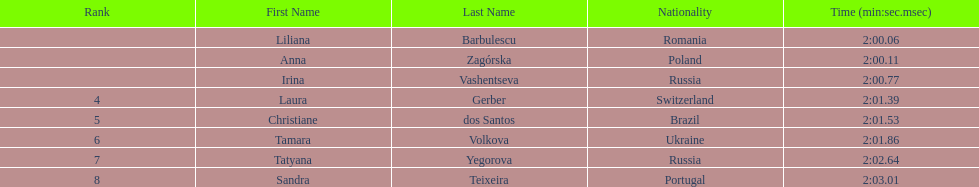How many runners finished with their time below 2:01? 3. 